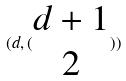<formula> <loc_0><loc_0><loc_500><loc_500>( d , ( \begin{matrix} d + 1 \\ 2 \end{matrix} ) )</formula> 